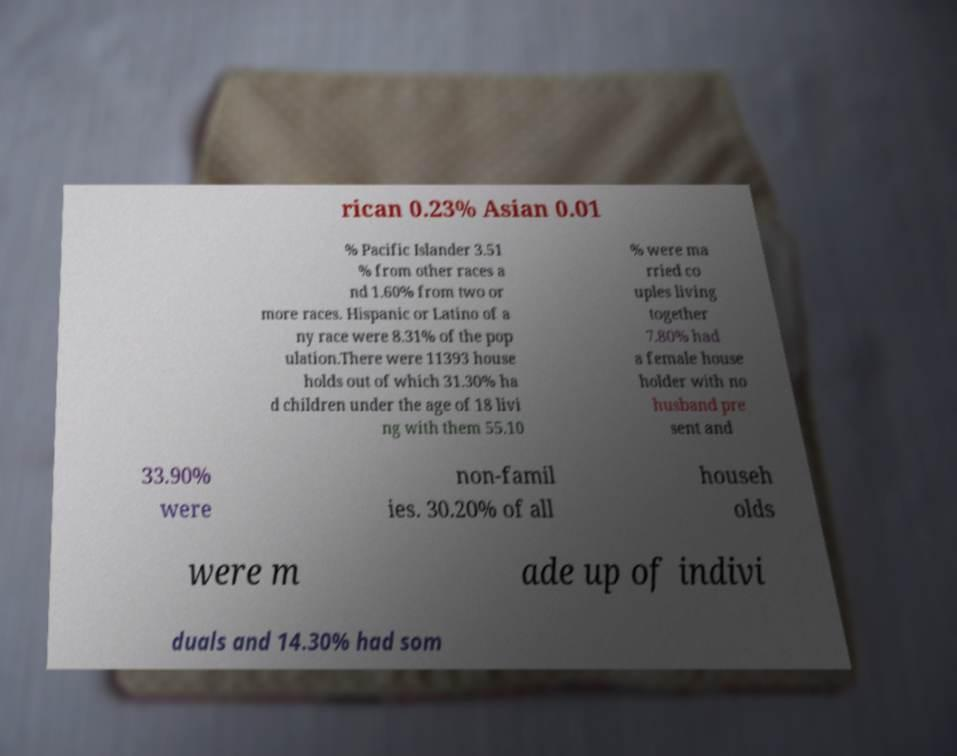There's text embedded in this image that I need extracted. Can you transcribe it verbatim? rican 0.23% Asian 0.01 % Pacific Islander 3.51 % from other races a nd 1.60% from two or more races. Hispanic or Latino of a ny race were 8.31% of the pop ulation.There were 11393 house holds out of which 31.30% ha d children under the age of 18 livi ng with them 55.10 % were ma rried co uples living together 7.80% had a female house holder with no husband pre sent and 33.90% were non-famil ies. 30.20% of all househ olds were m ade up of indivi duals and 14.30% had som 